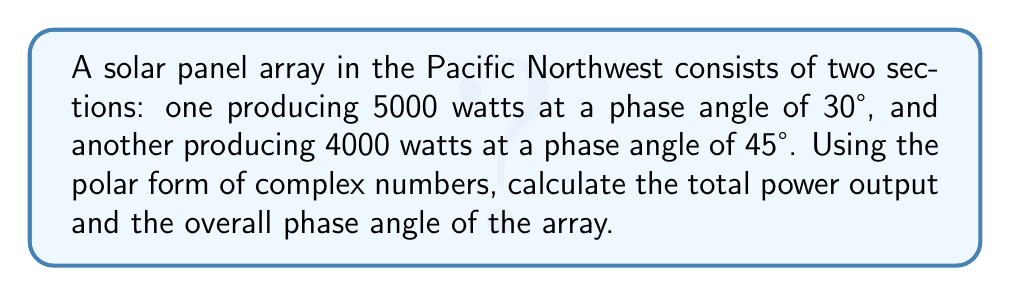Show me your answer to this math problem. Let's approach this step-by-step:

1) First, we need to express each section's output in polar form:
   Section 1: $5000 \angle 30°$
   Section 2: $4000 \angle 45°$

2) To add these complex numbers in polar form, we need to convert them to rectangular form:
   Section 1: $5000(\cos 30° + i \sin 30°) = 4330.13 + 2500i$
   Section 2: $4000(\cos 45° + i \sin 45°) = 2828.43 + 2828.43i$

3) Now we can add these rectangular forms:
   Total = $(4330.13 + 2500i) + (2828.43 + 2828.43i)$
         = $7158.56 + 5328.43i$

4) To convert this back to polar form, we need to calculate the magnitude and angle:

   Magnitude: $r = \sqrt{7158.56^2 + 5328.43^2} = 8944.27$

   Angle: $\theta = \tan^{-1}(\frac{5328.43}{7158.56}) = 36.67°$

5) Therefore, the total output in polar form is:
   $8944.27 \angle 36.67°$

This means the total power output is 8944.27 watts at a phase angle of 36.67°.
Answer: $8944.27 \angle 36.67°$ 